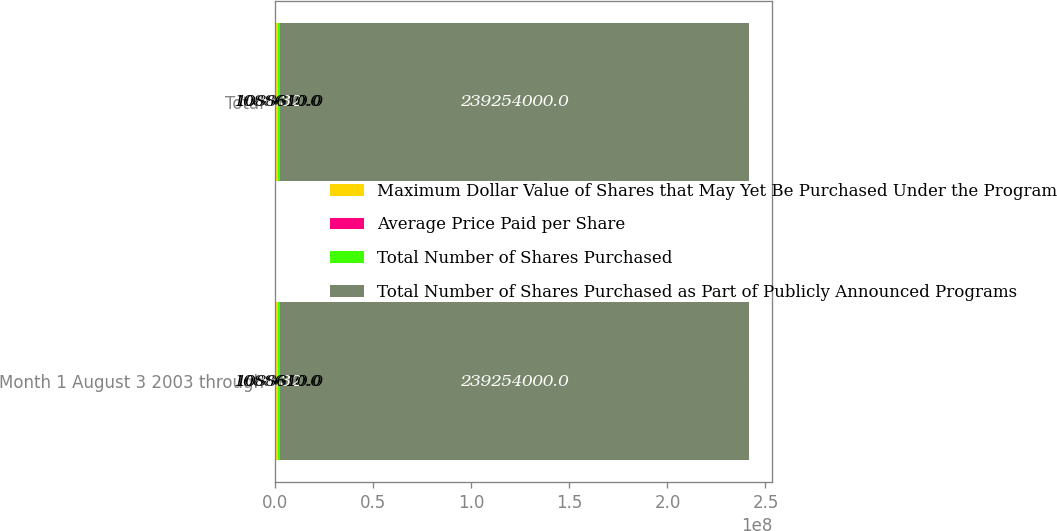Convert chart to OTSL. <chart><loc_0><loc_0><loc_500><loc_500><stacked_bar_chart><ecel><fcel>Month 1 August 3 2003 through<fcel>Total<nl><fcel>Maximum Dollar Value of Shares that May Yet Be Purchased Under the Programs<fcel>1.08861e+06<fcel>1.08861e+06<nl><fcel>Average Price Paid per Share<fcel>31.32<fcel>31.32<nl><fcel>Total Number of Shares Purchased<fcel>1.08861e+06<fcel>1.08861e+06<nl><fcel>Total Number of Shares Purchased as Part of Publicly Announced Programs<fcel>2.39254e+08<fcel>2.39254e+08<nl></chart> 